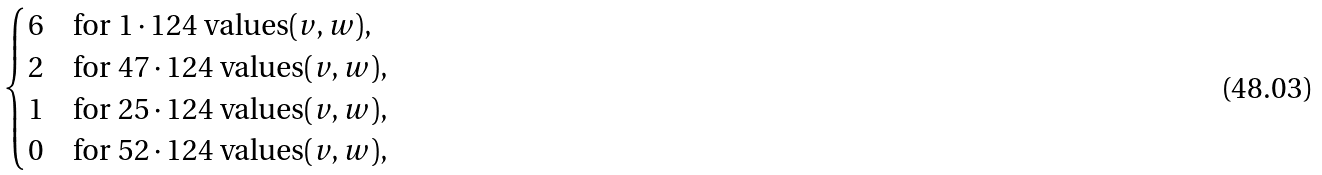<formula> <loc_0><loc_0><loc_500><loc_500>\begin{cases} 6 & \text {for } 1 \cdot 1 2 4 \text { values} ( v , w ) , \\ 2 & \text {for } 4 7 \cdot 1 2 4 \text { values} ( v , w ) , \\ 1 & \text {for } 2 5 \cdot 1 2 4 \text { values} ( v , w ) , \\ 0 & \text {for } 5 2 \cdot 1 2 4 \text { values} ( v , w ) , \end{cases}</formula> 